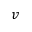Convert formula to latex. <formula><loc_0><loc_0><loc_500><loc_500>v</formula> 